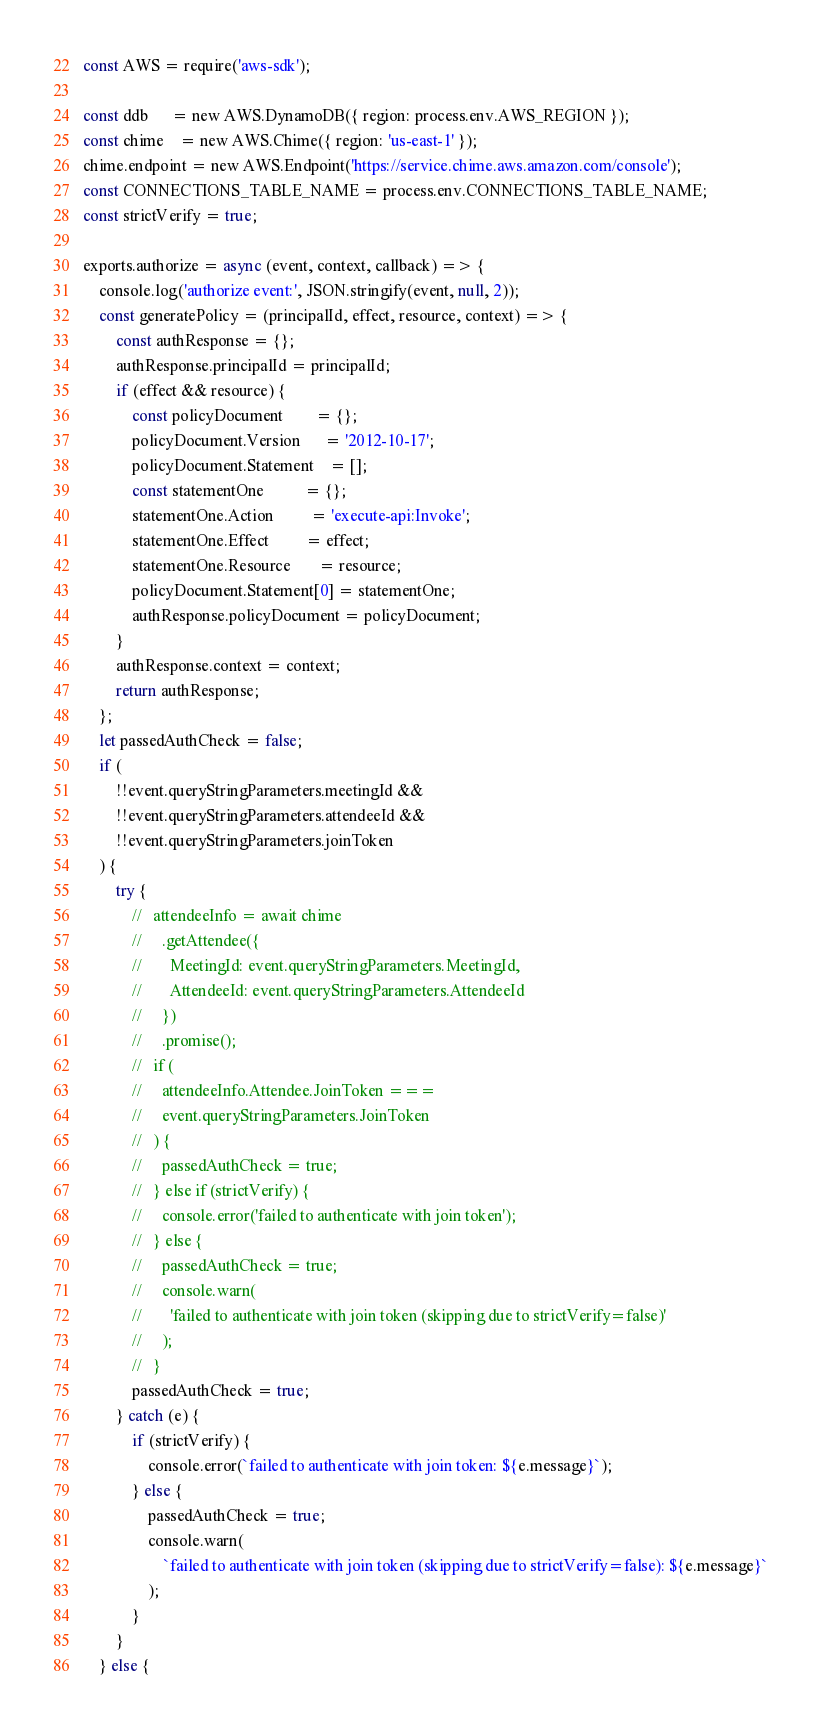<code> <loc_0><loc_0><loc_500><loc_500><_JavaScript_>const AWS = require('aws-sdk');

const ddb      = new AWS.DynamoDB({ region: process.env.AWS_REGION });
const chime    = new AWS.Chime({ region: 'us-east-1' });
chime.endpoint = new AWS.Endpoint('https://service.chime.aws.amazon.com/console');
const CONNECTIONS_TABLE_NAME = process.env.CONNECTIONS_TABLE_NAME;
const strictVerify = true;

exports.authorize = async (event, context, callback) => {
    console.log('authorize event:', JSON.stringify(event, null, 2));
    const generatePolicy = (principalId, effect, resource, context) => {
        const authResponse = {};
        authResponse.principalId = principalId;
        if (effect && resource) {
            const policyDocument        = {};
            policyDocument.Version      = '2012-10-17';
            policyDocument.Statement    = [];
            const statementOne          = {};
            statementOne.Action         = 'execute-api:Invoke';
            statementOne.Effect         = effect;
            statementOne.Resource       = resource;
            policyDocument.Statement[0] = statementOne;
            authResponse.policyDocument = policyDocument;
        }
        authResponse.context = context;
        return authResponse;
    };
    let passedAuthCheck = false;
    if (
        !!event.queryStringParameters.meetingId &&
        !!event.queryStringParameters.attendeeId &&
        !!event.queryStringParameters.joinToken
    ) {
        try {
            //   attendeeInfo = await chime
            //     .getAttendee({
            //       MeetingId: event.queryStringParameters.MeetingId,
            //       AttendeeId: event.queryStringParameters.AttendeeId
            //     })
            //     .promise();
            //   if (
            //     attendeeInfo.Attendee.JoinToken ===
            //     event.queryStringParameters.JoinToken
            //   ) {
            //     passedAuthCheck = true;
            //   } else if (strictVerify) {
            //     console.error('failed to authenticate with join token');
            //   } else {
            //     passedAuthCheck = true;
            //     console.warn(
            //       'failed to authenticate with join token (skipping due to strictVerify=false)'
            //     );
            //   }
            passedAuthCheck = true;
        } catch (e) {
            if (strictVerify) {
                console.error(`failed to authenticate with join token: ${e.message}`);
            } else {
                passedAuthCheck = true;
                console.warn(
                    `failed to authenticate with join token (skipping due to strictVerify=false): ${e.message}`
                );
            }
        }
    } else {</code> 